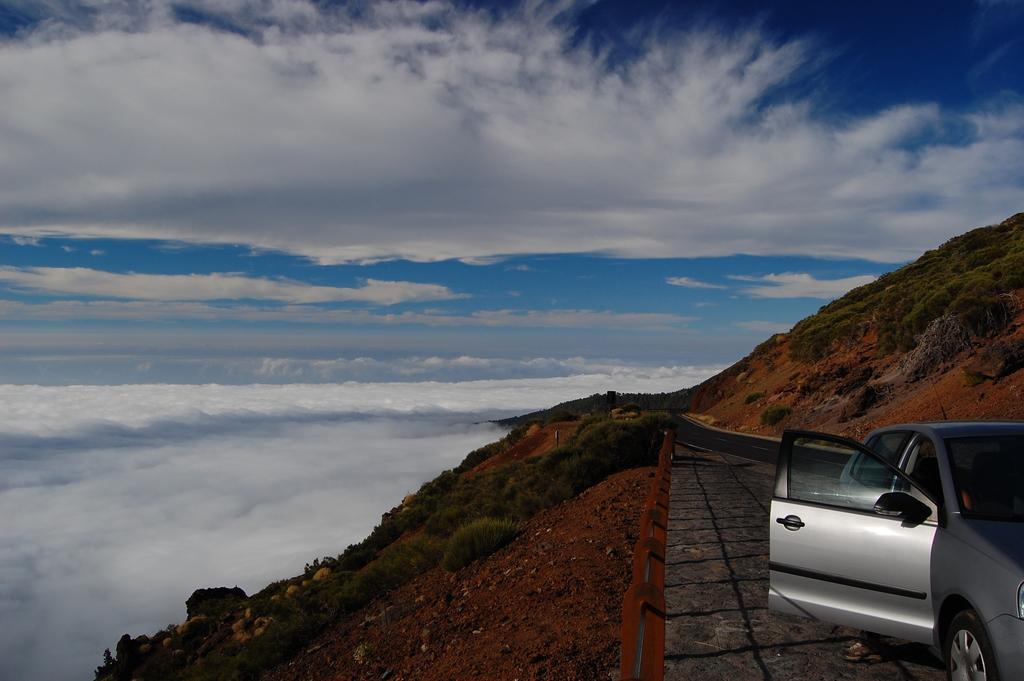In one or two sentences, can you explain what this image depicts? In this image I can see the vehicle. In the background I can see few trees in green color and the sky is in blue and white color. 